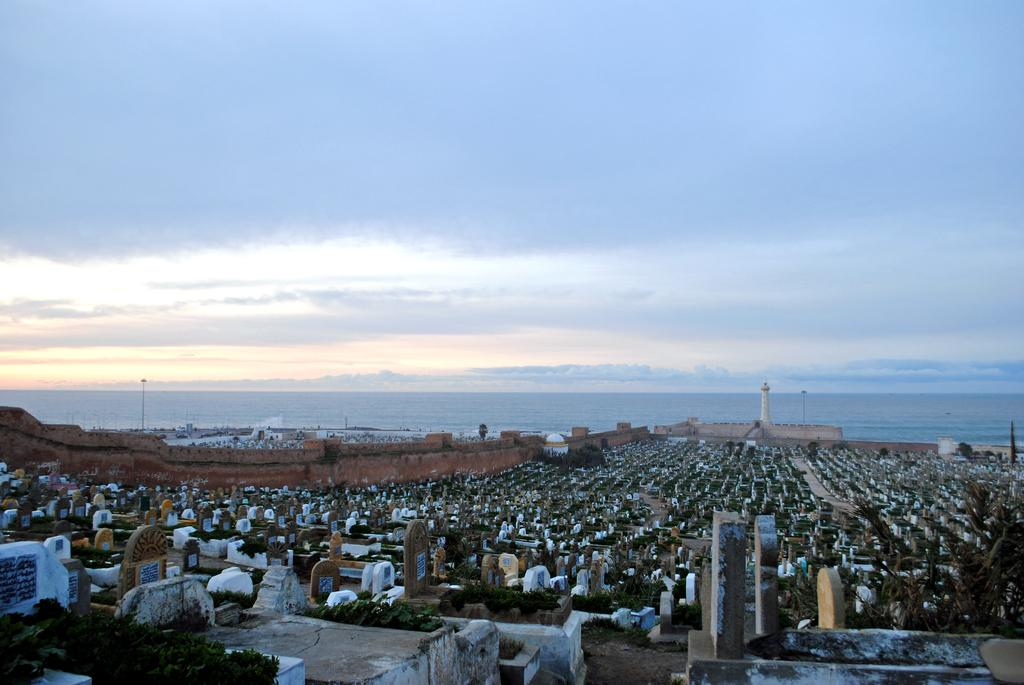What type of location is depicted in the image? There is a graveyard in the image. What other structure can be seen in the image? There is a lighthouse in the image. Where is the lighthouse located in relation to the seashore? The lighthouse is near the seashore. How would you describe the sky in the image? The sky is clear in the image. What type of music is playing in the background of the image? There is no music present in the image; it only shows a graveyard and a lighthouse near the seashore. Is there an oven visible in the image? No, there is no oven present in the image. 